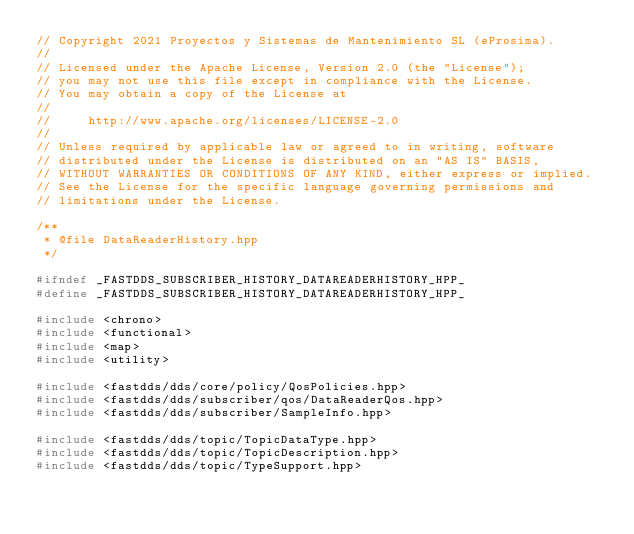<code> <loc_0><loc_0><loc_500><loc_500><_C++_>// Copyright 2021 Proyectos y Sistemas de Mantenimiento SL (eProsima).
//
// Licensed under the Apache License, Version 2.0 (the "License");
// you may not use this file except in compliance with the License.
// You may obtain a copy of the License at
//
//     http://www.apache.org/licenses/LICENSE-2.0
//
// Unless required by applicable law or agreed to in writing, software
// distributed under the License is distributed on an "AS IS" BASIS,
// WITHOUT WARRANTIES OR CONDITIONS OF ANY KIND, either express or implied.
// See the License for the specific language governing permissions and
// limitations under the License.

/**
 * @file DataReaderHistory.hpp
 */

#ifndef _FASTDDS_SUBSCRIBER_HISTORY_DATAREADERHISTORY_HPP_
#define _FASTDDS_SUBSCRIBER_HISTORY_DATAREADERHISTORY_HPP_

#include <chrono>
#include <functional>
#include <map>
#include <utility>

#include <fastdds/dds/core/policy/QosPolicies.hpp>
#include <fastdds/dds/subscriber/qos/DataReaderQos.hpp>
#include <fastdds/dds/subscriber/SampleInfo.hpp>

#include <fastdds/dds/topic/TopicDataType.hpp>
#include <fastdds/dds/topic/TopicDescription.hpp>
#include <fastdds/dds/topic/TypeSupport.hpp>
</code> 